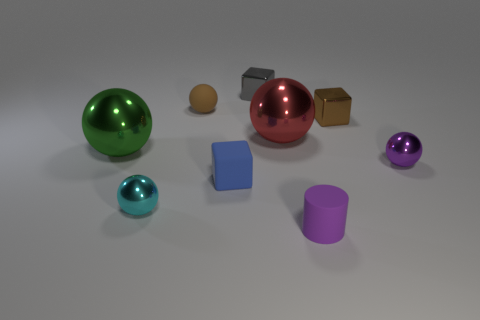There is a matte thing that is both in front of the big red shiny ball and behind the tiny purple cylinder; what is its size?
Give a very brief answer. Small. There is a small brown thing on the right side of the small blue object; what material is it?
Offer a terse response. Metal. Does the rubber sphere have the same color as the metal sphere that is on the right side of the tiny cylinder?
Your response must be concise. No. How many things are tiny brown objects that are to the left of the small matte block or objects behind the tiny blue thing?
Your answer should be very brief. 6. What is the color of the tiny metal object that is both in front of the small gray shiny cube and left of the brown metal thing?
Ensure brevity in your answer.  Cyan. Is the number of large purple rubber cylinders greater than the number of brown matte things?
Your answer should be very brief. No. Is the shape of the small brown object that is to the left of the red ball the same as  the small cyan metal thing?
Provide a short and direct response. Yes. How many metallic things are either brown cubes or purple spheres?
Ensure brevity in your answer.  2. Are there any balls that have the same material as the gray thing?
Provide a succinct answer. Yes. What material is the red ball?
Offer a very short reply. Metal. 